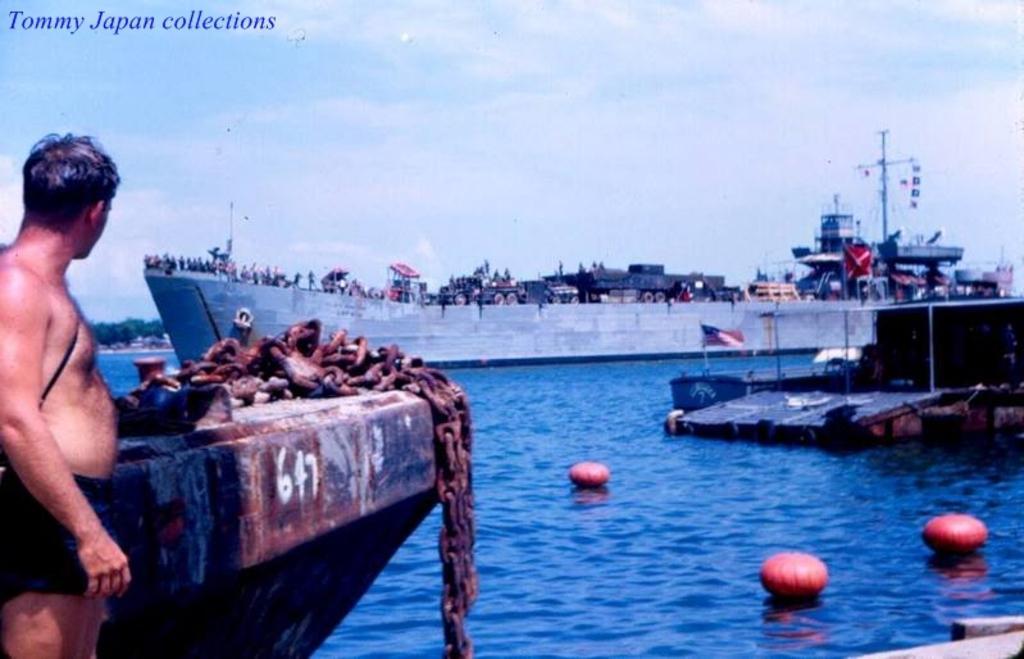Can you describe this image briefly? In this image there is water at the bottom. In the water there are pumpkins. On the left side there is a person standing beside the boat. On the boat there are chains. In the background there is a ship in the water. In the ship there are so many people standing on it. At the top there is the sky. On the right side there is a flag beside another boat. 